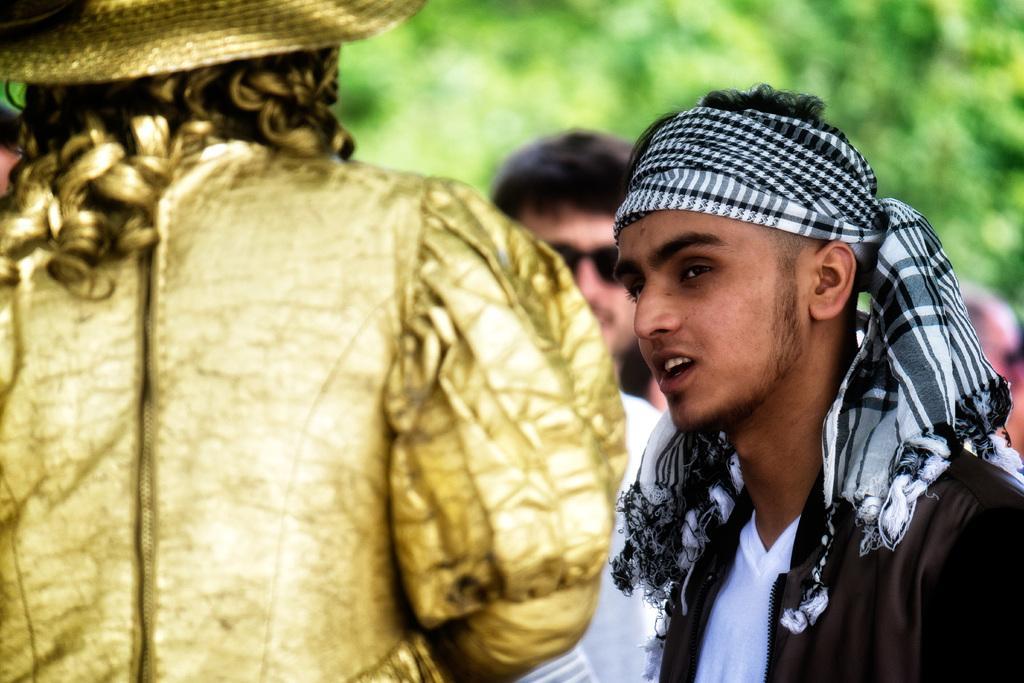How would you summarize this image in a sentence or two? On the left side of the image we can see this person wearing gold dress and hat. On the right side of the image we can see this person wearing black jacket and scarf on his head. The background of the image is slightly blurred, where we can see a person and trees. 